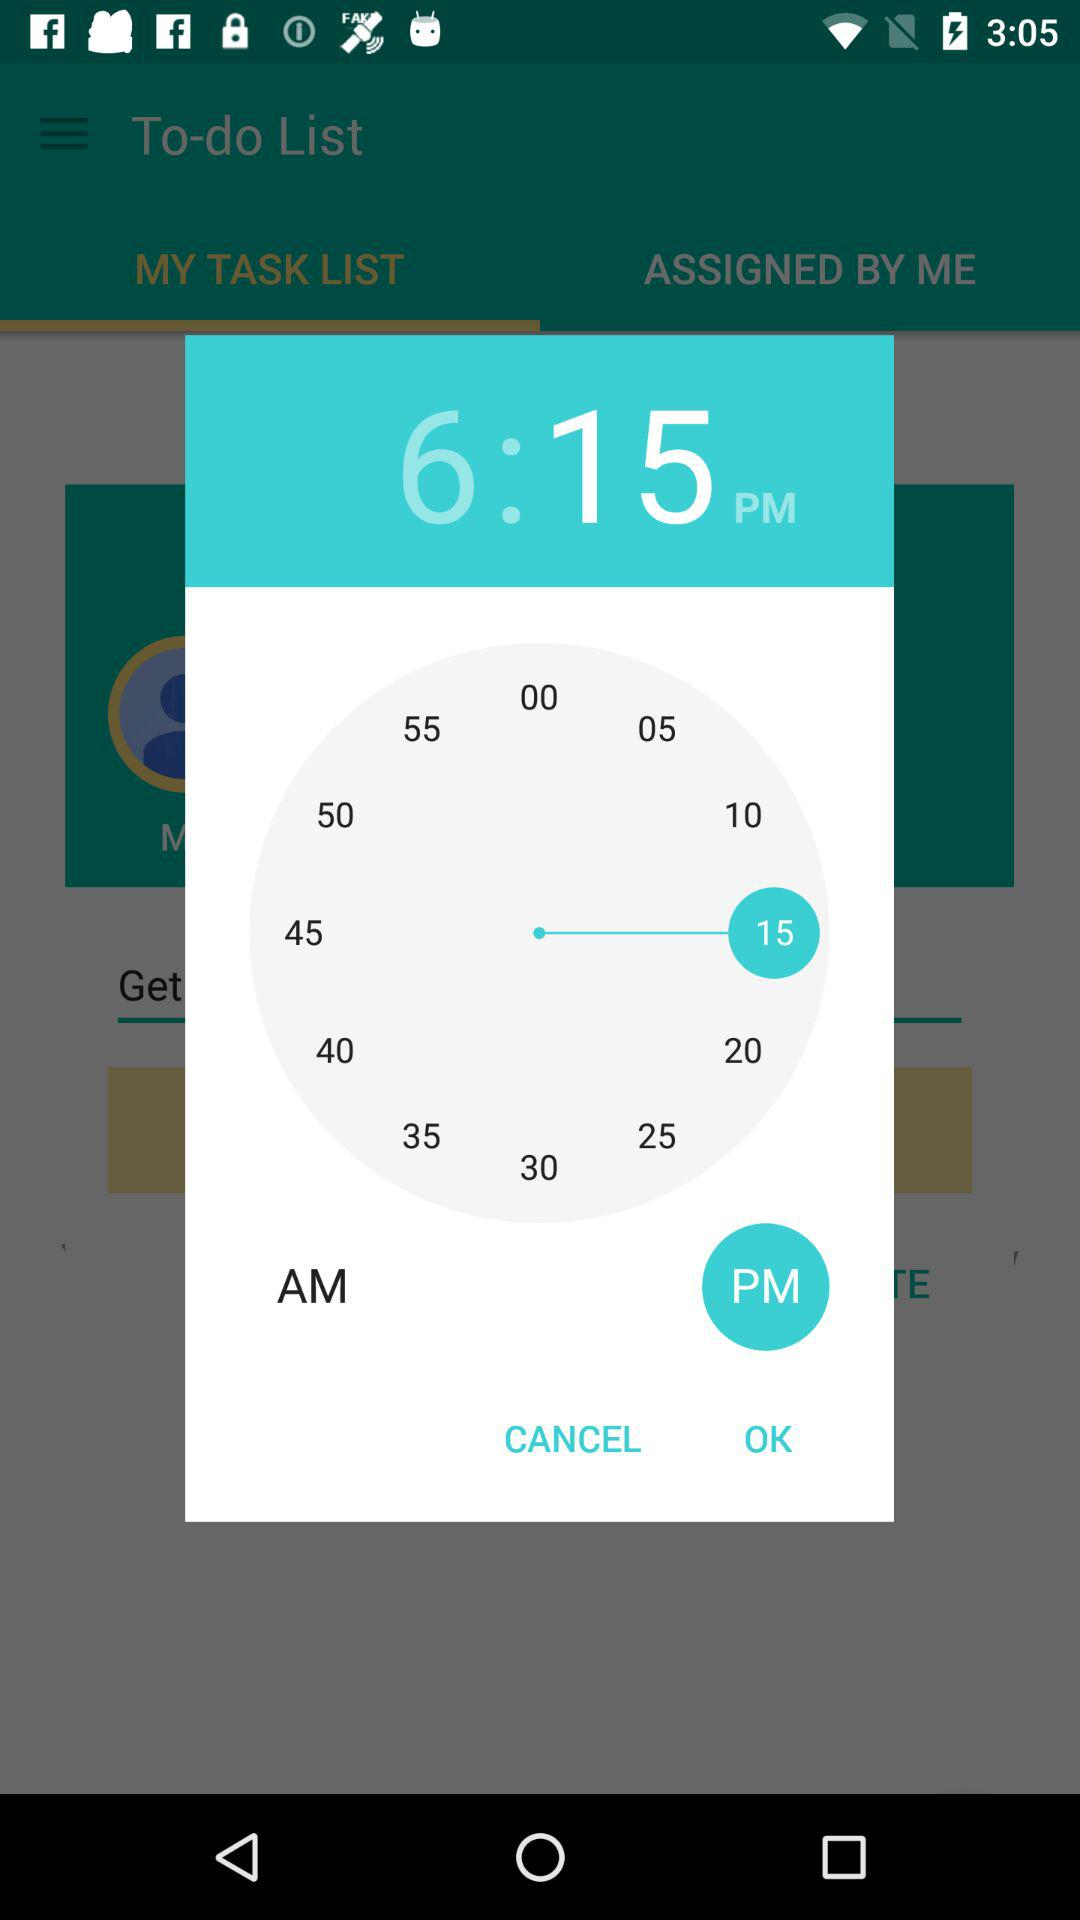What is the set time? The set time is 6:15 PM. 